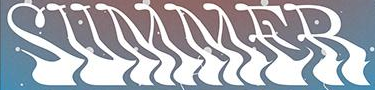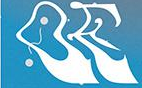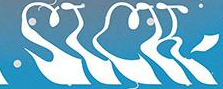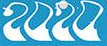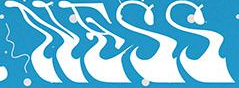Identify the words shown in these images in order, separated by a semicolon. SUMMER; OE; SICK; 2020; NESS 